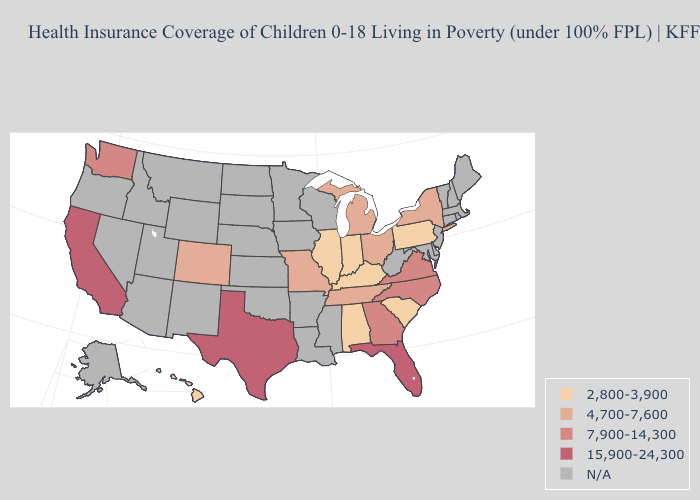Does the map have missing data?
Quick response, please. Yes. Name the states that have a value in the range 7,900-14,300?
Be succinct. Georgia, North Carolina, Virginia, Washington. Name the states that have a value in the range 7,900-14,300?
Quick response, please. Georgia, North Carolina, Virginia, Washington. What is the lowest value in the MidWest?
Write a very short answer. 2,800-3,900. What is the highest value in the USA?
Give a very brief answer. 15,900-24,300. What is the value of Hawaii?
Write a very short answer. 2,800-3,900. Does the first symbol in the legend represent the smallest category?
Answer briefly. Yes. Does Texas have the lowest value in the USA?
Short answer required. No. Name the states that have a value in the range 4,700-7,600?
Be succinct. Colorado, Michigan, Missouri, New York, Ohio, Tennessee. What is the lowest value in the South?
Quick response, please. 2,800-3,900. What is the highest value in the USA?
Give a very brief answer. 15,900-24,300. Does Michigan have the highest value in the MidWest?
Write a very short answer. Yes. Which states have the highest value in the USA?
Short answer required. California, Florida, Texas. Name the states that have a value in the range N/A?
Concise answer only. Alaska, Arizona, Arkansas, Connecticut, Delaware, Idaho, Iowa, Kansas, Louisiana, Maine, Maryland, Massachusetts, Minnesota, Mississippi, Montana, Nebraska, Nevada, New Hampshire, New Jersey, New Mexico, North Dakota, Oklahoma, Oregon, Rhode Island, South Dakota, Utah, Vermont, West Virginia, Wisconsin, Wyoming. What is the value of North Dakota?
Concise answer only. N/A. 